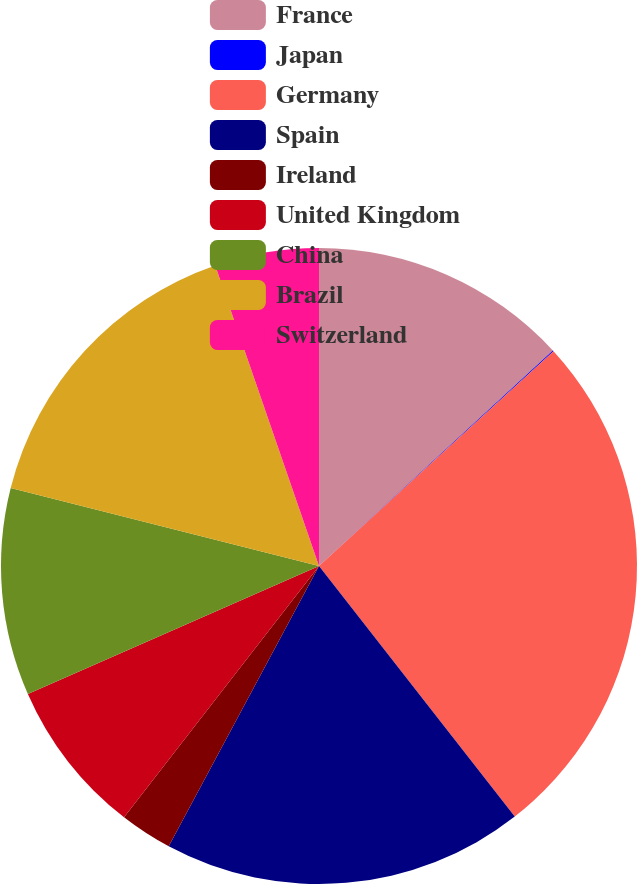Convert chart to OTSL. <chart><loc_0><loc_0><loc_500><loc_500><pie_chart><fcel>France<fcel>Japan<fcel>Germany<fcel>Spain<fcel>Ireland<fcel>United Kingdom<fcel>China<fcel>Brazil<fcel>Switzerland<nl><fcel>13.15%<fcel>0.05%<fcel>26.25%<fcel>18.39%<fcel>2.67%<fcel>7.91%<fcel>10.53%<fcel>15.77%<fcel>5.29%<nl></chart> 